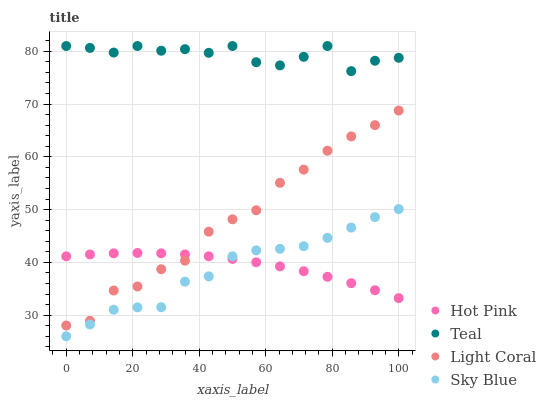Does Sky Blue have the minimum area under the curve?
Answer yes or no. Yes. Does Teal have the maximum area under the curve?
Answer yes or no. Yes. Does Hot Pink have the minimum area under the curve?
Answer yes or no. No. Does Hot Pink have the maximum area under the curve?
Answer yes or no. No. Is Hot Pink the smoothest?
Answer yes or no. Yes. Is Teal the roughest?
Answer yes or no. Yes. Is Sky Blue the smoothest?
Answer yes or no. No. Is Sky Blue the roughest?
Answer yes or no. No. Does Sky Blue have the lowest value?
Answer yes or no. Yes. Does Hot Pink have the lowest value?
Answer yes or no. No. Does Teal have the highest value?
Answer yes or no. Yes. Does Sky Blue have the highest value?
Answer yes or no. No. Is Hot Pink less than Teal?
Answer yes or no. Yes. Is Light Coral greater than Sky Blue?
Answer yes or no. Yes. Does Hot Pink intersect Sky Blue?
Answer yes or no. Yes. Is Hot Pink less than Sky Blue?
Answer yes or no. No. Is Hot Pink greater than Sky Blue?
Answer yes or no. No. Does Hot Pink intersect Teal?
Answer yes or no. No. 